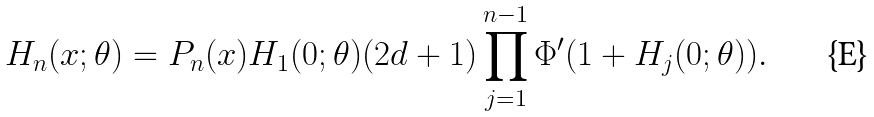Convert formula to latex. <formula><loc_0><loc_0><loc_500><loc_500>H _ { n } ( x ; \theta ) = P _ { n } ( x ) H _ { 1 } ( 0 ; \theta ) ( 2 d + 1 ) \prod _ { j = 1 } ^ { n - 1 } \Phi ^ { \prime } ( 1 + H _ { j } ( 0 ; \theta ) ) .</formula> 